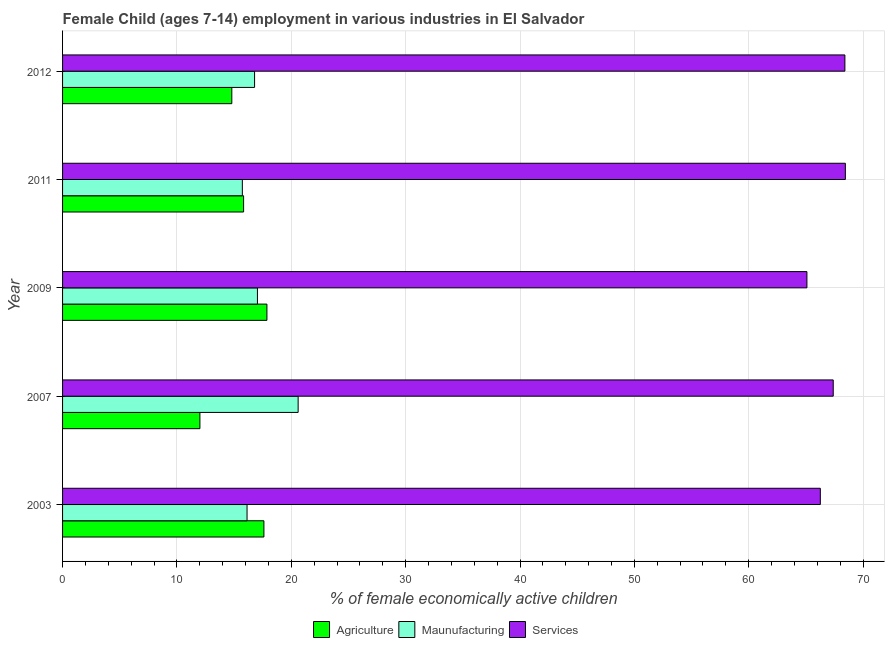How many different coloured bars are there?
Give a very brief answer. 3. How many groups of bars are there?
Ensure brevity in your answer.  5. Are the number of bars per tick equal to the number of legend labels?
Make the answer very short. Yes. Are the number of bars on each tick of the Y-axis equal?
Your response must be concise. Yes. What is the percentage of economically active children in agriculture in 2012?
Your answer should be very brief. 14.8. Across all years, what is the maximum percentage of economically active children in manufacturing?
Your answer should be compact. 20.6. Across all years, what is the minimum percentage of economically active children in services?
Ensure brevity in your answer.  65.09. In which year was the percentage of economically active children in services maximum?
Keep it short and to the point. 2011. In which year was the percentage of economically active children in services minimum?
Provide a short and direct response. 2009. What is the total percentage of economically active children in services in the graph?
Your answer should be very brief. 335.6. What is the difference between the percentage of economically active children in manufacturing in 2007 and that in 2011?
Make the answer very short. 4.88. What is the difference between the percentage of economically active children in agriculture in 2007 and the percentage of economically active children in services in 2003?
Provide a short and direct response. -54.25. What is the average percentage of economically active children in manufacturing per year?
Provide a succinct answer. 17.26. In the year 2003, what is the difference between the percentage of economically active children in manufacturing and percentage of economically active children in services?
Your response must be concise. -50.13. What is the difference between the highest and the lowest percentage of economically active children in manufacturing?
Keep it short and to the point. 4.88. Is the sum of the percentage of economically active children in services in 2003 and 2009 greater than the maximum percentage of economically active children in manufacturing across all years?
Your answer should be compact. Yes. What does the 3rd bar from the top in 2003 represents?
Provide a short and direct response. Agriculture. What does the 2nd bar from the bottom in 2012 represents?
Your answer should be compact. Maunufacturing. How many bars are there?
Provide a succinct answer. 15. How many years are there in the graph?
Make the answer very short. 5. What is the difference between two consecutive major ticks on the X-axis?
Offer a terse response. 10. Does the graph contain grids?
Provide a succinct answer. Yes. How many legend labels are there?
Your answer should be very brief. 3. What is the title of the graph?
Make the answer very short. Female Child (ages 7-14) employment in various industries in El Salvador. What is the label or title of the X-axis?
Ensure brevity in your answer.  % of female economically active children. What is the label or title of the Y-axis?
Your response must be concise. Year. What is the % of female economically active children in Agriculture in 2003?
Your answer should be compact. 17.61. What is the % of female economically active children in Maunufacturing in 2003?
Offer a terse response. 16.13. What is the % of female economically active children of Services in 2003?
Make the answer very short. 66.26. What is the % of female economically active children in Agriculture in 2007?
Provide a succinct answer. 12.01. What is the % of female economically active children of Maunufacturing in 2007?
Offer a very short reply. 20.6. What is the % of female economically active children in Services in 2007?
Give a very brief answer. 67.39. What is the % of female economically active children of Agriculture in 2009?
Give a very brief answer. 17.87. What is the % of female economically active children in Maunufacturing in 2009?
Your answer should be compact. 17.04. What is the % of female economically active children of Services in 2009?
Your answer should be compact. 65.09. What is the % of female economically active children of Agriculture in 2011?
Offer a terse response. 15.83. What is the % of female economically active children of Maunufacturing in 2011?
Make the answer very short. 15.72. What is the % of female economically active children in Services in 2011?
Make the answer very short. 68.45. What is the % of female economically active children of Maunufacturing in 2012?
Provide a succinct answer. 16.79. What is the % of female economically active children in Services in 2012?
Your answer should be very brief. 68.41. Across all years, what is the maximum % of female economically active children in Agriculture?
Keep it short and to the point. 17.87. Across all years, what is the maximum % of female economically active children in Maunufacturing?
Make the answer very short. 20.6. Across all years, what is the maximum % of female economically active children in Services?
Ensure brevity in your answer.  68.45. Across all years, what is the minimum % of female economically active children of Agriculture?
Your answer should be compact. 12.01. Across all years, what is the minimum % of female economically active children in Maunufacturing?
Your response must be concise. 15.72. Across all years, what is the minimum % of female economically active children in Services?
Your answer should be very brief. 65.09. What is the total % of female economically active children of Agriculture in the graph?
Offer a very short reply. 78.12. What is the total % of female economically active children in Maunufacturing in the graph?
Make the answer very short. 86.28. What is the total % of female economically active children in Services in the graph?
Offer a terse response. 335.6. What is the difference between the % of female economically active children in Agriculture in 2003 and that in 2007?
Your answer should be compact. 5.6. What is the difference between the % of female economically active children of Maunufacturing in 2003 and that in 2007?
Offer a very short reply. -4.47. What is the difference between the % of female economically active children of Services in 2003 and that in 2007?
Provide a succinct answer. -1.13. What is the difference between the % of female economically active children of Agriculture in 2003 and that in 2009?
Make the answer very short. -0.26. What is the difference between the % of female economically active children of Maunufacturing in 2003 and that in 2009?
Give a very brief answer. -0.91. What is the difference between the % of female economically active children of Services in 2003 and that in 2009?
Make the answer very short. 1.17. What is the difference between the % of female economically active children in Agriculture in 2003 and that in 2011?
Offer a terse response. 1.78. What is the difference between the % of female economically active children in Maunufacturing in 2003 and that in 2011?
Keep it short and to the point. 0.41. What is the difference between the % of female economically active children of Services in 2003 and that in 2011?
Your response must be concise. -2.19. What is the difference between the % of female economically active children of Agriculture in 2003 and that in 2012?
Offer a terse response. 2.81. What is the difference between the % of female economically active children in Maunufacturing in 2003 and that in 2012?
Keep it short and to the point. -0.66. What is the difference between the % of female economically active children in Services in 2003 and that in 2012?
Your answer should be very brief. -2.15. What is the difference between the % of female economically active children of Agriculture in 2007 and that in 2009?
Offer a terse response. -5.86. What is the difference between the % of female economically active children of Maunufacturing in 2007 and that in 2009?
Keep it short and to the point. 3.56. What is the difference between the % of female economically active children of Agriculture in 2007 and that in 2011?
Give a very brief answer. -3.82. What is the difference between the % of female economically active children in Maunufacturing in 2007 and that in 2011?
Your answer should be very brief. 4.88. What is the difference between the % of female economically active children in Services in 2007 and that in 2011?
Give a very brief answer. -1.06. What is the difference between the % of female economically active children of Agriculture in 2007 and that in 2012?
Ensure brevity in your answer.  -2.79. What is the difference between the % of female economically active children of Maunufacturing in 2007 and that in 2012?
Keep it short and to the point. 3.81. What is the difference between the % of female economically active children in Services in 2007 and that in 2012?
Your response must be concise. -1.02. What is the difference between the % of female economically active children of Agriculture in 2009 and that in 2011?
Your answer should be very brief. 2.04. What is the difference between the % of female economically active children in Maunufacturing in 2009 and that in 2011?
Provide a short and direct response. 1.32. What is the difference between the % of female economically active children in Services in 2009 and that in 2011?
Your answer should be compact. -3.36. What is the difference between the % of female economically active children of Agriculture in 2009 and that in 2012?
Your answer should be compact. 3.07. What is the difference between the % of female economically active children in Services in 2009 and that in 2012?
Make the answer very short. -3.32. What is the difference between the % of female economically active children in Maunufacturing in 2011 and that in 2012?
Keep it short and to the point. -1.07. What is the difference between the % of female economically active children in Agriculture in 2003 and the % of female economically active children in Maunufacturing in 2007?
Give a very brief answer. -2.99. What is the difference between the % of female economically active children of Agriculture in 2003 and the % of female economically active children of Services in 2007?
Give a very brief answer. -49.78. What is the difference between the % of female economically active children in Maunufacturing in 2003 and the % of female economically active children in Services in 2007?
Ensure brevity in your answer.  -51.26. What is the difference between the % of female economically active children in Agriculture in 2003 and the % of female economically active children in Maunufacturing in 2009?
Offer a very short reply. 0.57. What is the difference between the % of female economically active children of Agriculture in 2003 and the % of female economically active children of Services in 2009?
Provide a short and direct response. -47.48. What is the difference between the % of female economically active children of Maunufacturing in 2003 and the % of female economically active children of Services in 2009?
Your answer should be very brief. -48.96. What is the difference between the % of female economically active children in Agriculture in 2003 and the % of female economically active children in Maunufacturing in 2011?
Ensure brevity in your answer.  1.89. What is the difference between the % of female economically active children of Agriculture in 2003 and the % of female economically active children of Services in 2011?
Your answer should be very brief. -50.84. What is the difference between the % of female economically active children in Maunufacturing in 2003 and the % of female economically active children in Services in 2011?
Offer a very short reply. -52.32. What is the difference between the % of female economically active children in Agriculture in 2003 and the % of female economically active children in Maunufacturing in 2012?
Provide a short and direct response. 0.82. What is the difference between the % of female economically active children in Agriculture in 2003 and the % of female economically active children in Services in 2012?
Keep it short and to the point. -50.8. What is the difference between the % of female economically active children in Maunufacturing in 2003 and the % of female economically active children in Services in 2012?
Make the answer very short. -52.28. What is the difference between the % of female economically active children in Agriculture in 2007 and the % of female economically active children in Maunufacturing in 2009?
Provide a short and direct response. -5.03. What is the difference between the % of female economically active children of Agriculture in 2007 and the % of female economically active children of Services in 2009?
Your answer should be compact. -53.08. What is the difference between the % of female economically active children of Maunufacturing in 2007 and the % of female economically active children of Services in 2009?
Give a very brief answer. -44.49. What is the difference between the % of female economically active children of Agriculture in 2007 and the % of female economically active children of Maunufacturing in 2011?
Your answer should be compact. -3.71. What is the difference between the % of female economically active children of Agriculture in 2007 and the % of female economically active children of Services in 2011?
Provide a short and direct response. -56.44. What is the difference between the % of female economically active children of Maunufacturing in 2007 and the % of female economically active children of Services in 2011?
Give a very brief answer. -47.85. What is the difference between the % of female economically active children in Agriculture in 2007 and the % of female economically active children in Maunufacturing in 2012?
Your answer should be compact. -4.78. What is the difference between the % of female economically active children in Agriculture in 2007 and the % of female economically active children in Services in 2012?
Your answer should be compact. -56.4. What is the difference between the % of female economically active children in Maunufacturing in 2007 and the % of female economically active children in Services in 2012?
Your response must be concise. -47.81. What is the difference between the % of female economically active children of Agriculture in 2009 and the % of female economically active children of Maunufacturing in 2011?
Provide a succinct answer. 2.15. What is the difference between the % of female economically active children in Agriculture in 2009 and the % of female economically active children in Services in 2011?
Provide a short and direct response. -50.58. What is the difference between the % of female economically active children in Maunufacturing in 2009 and the % of female economically active children in Services in 2011?
Make the answer very short. -51.41. What is the difference between the % of female economically active children in Agriculture in 2009 and the % of female economically active children in Maunufacturing in 2012?
Your answer should be very brief. 1.08. What is the difference between the % of female economically active children of Agriculture in 2009 and the % of female economically active children of Services in 2012?
Keep it short and to the point. -50.54. What is the difference between the % of female economically active children of Maunufacturing in 2009 and the % of female economically active children of Services in 2012?
Your answer should be very brief. -51.37. What is the difference between the % of female economically active children in Agriculture in 2011 and the % of female economically active children in Maunufacturing in 2012?
Make the answer very short. -0.96. What is the difference between the % of female economically active children in Agriculture in 2011 and the % of female economically active children in Services in 2012?
Offer a very short reply. -52.58. What is the difference between the % of female economically active children in Maunufacturing in 2011 and the % of female economically active children in Services in 2012?
Provide a succinct answer. -52.69. What is the average % of female economically active children in Agriculture per year?
Your answer should be very brief. 15.62. What is the average % of female economically active children of Maunufacturing per year?
Offer a very short reply. 17.26. What is the average % of female economically active children in Services per year?
Make the answer very short. 67.12. In the year 2003, what is the difference between the % of female economically active children of Agriculture and % of female economically active children of Maunufacturing?
Your response must be concise. 1.47. In the year 2003, what is the difference between the % of female economically active children of Agriculture and % of female economically active children of Services?
Provide a succinct answer. -48.66. In the year 2003, what is the difference between the % of female economically active children of Maunufacturing and % of female economically active children of Services?
Your response must be concise. -50.13. In the year 2007, what is the difference between the % of female economically active children in Agriculture and % of female economically active children in Maunufacturing?
Make the answer very short. -8.59. In the year 2007, what is the difference between the % of female economically active children in Agriculture and % of female economically active children in Services?
Your answer should be compact. -55.38. In the year 2007, what is the difference between the % of female economically active children of Maunufacturing and % of female economically active children of Services?
Your response must be concise. -46.79. In the year 2009, what is the difference between the % of female economically active children in Agriculture and % of female economically active children in Maunufacturing?
Offer a very short reply. 0.83. In the year 2009, what is the difference between the % of female economically active children of Agriculture and % of female economically active children of Services?
Provide a short and direct response. -47.22. In the year 2009, what is the difference between the % of female economically active children of Maunufacturing and % of female economically active children of Services?
Keep it short and to the point. -48.05. In the year 2011, what is the difference between the % of female economically active children in Agriculture and % of female economically active children in Maunufacturing?
Offer a very short reply. 0.11. In the year 2011, what is the difference between the % of female economically active children in Agriculture and % of female economically active children in Services?
Your answer should be very brief. -52.62. In the year 2011, what is the difference between the % of female economically active children in Maunufacturing and % of female economically active children in Services?
Keep it short and to the point. -52.73. In the year 2012, what is the difference between the % of female economically active children of Agriculture and % of female economically active children of Maunufacturing?
Your response must be concise. -1.99. In the year 2012, what is the difference between the % of female economically active children in Agriculture and % of female economically active children in Services?
Ensure brevity in your answer.  -53.61. In the year 2012, what is the difference between the % of female economically active children in Maunufacturing and % of female economically active children in Services?
Provide a short and direct response. -51.62. What is the ratio of the % of female economically active children of Agriculture in 2003 to that in 2007?
Your response must be concise. 1.47. What is the ratio of the % of female economically active children in Maunufacturing in 2003 to that in 2007?
Provide a succinct answer. 0.78. What is the ratio of the % of female economically active children in Services in 2003 to that in 2007?
Offer a terse response. 0.98. What is the ratio of the % of female economically active children of Agriculture in 2003 to that in 2009?
Provide a succinct answer. 0.99. What is the ratio of the % of female economically active children in Maunufacturing in 2003 to that in 2009?
Your answer should be compact. 0.95. What is the ratio of the % of female economically active children of Services in 2003 to that in 2009?
Make the answer very short. 1.02. What is the ratio of the % of female economically active children of Agriculture in 2003 to that in 2011?
Ensure brevity in your answer.  1.11. What is the ratio of the % of female economically active children in Maunufacturing in 2003 to that in 2011?
Offer a terse response. 1.03. What is the ratio of the % of female economically active children in Agriculture in 2003 to that in 2012?
Offer a very short reply. 1.19. What is the ratio of the % of female economically active children in Maunufacturing in 2003 to that in 2012?
Your answer should be compact. 0.96. What is the ratio of the % of female economically active children of Services in 2003 to that in 2012?
Your answer should be very brief. 0.97. What is the ratio of the % of female economically active children in Agriculture in 2007 to that in 2009?
Provide a short and direct response. 0.67. What is the ratio of the % of female economically active children of Maunufacturing in 2007 to that in 2009?
Make the answer very short. 1.21. What is the ratio of the % of female economically active children of Services in 2007 to that in 2009?
Your answer should be compact. 1.04. What is the ratio of the % of female economically active children of Agriculture in 2007 to that in 2011?
Provide a succinct answer. 0.76. What is the ratio of the % of female economically active children in Maunufacturing in 2007 to that in 2011?
Offer a very short reply. 1.31. What is the ratio of the % of female economically active children in Services in 2007 to that in 2011?
Offer a very short reply. 0.98. What is the ratio of the % of female economically active children in Agriculture in 2007 to that in 2012?
Your response must be concise. 0.81. What is the ratio of the % of female economically active children of Maunufacturing in 2007 to that in 2012?
Offer a terse response. 1.23. What is the ratio of the % of female economically active children of Services in 2007 to that in 2012?
Make the answer very short. 0.99. What is the ratio of the % of female economically active children of Agriculture in 2009 to that in 2011?
Your answer should be very brief. 1.13. What is the ratio of the % of female economically active children in Maunufacturing in 2009 to that in 2011?
Your response must be concise. 1.08. What is the ratio of the % of female economically active children of Services in 2009 to that in 2011?
Your response must be concise. 0.95. What is the ratio of the % of female economically active children in Agriculture in 2009 to that in 2012?
Your response must be concise. 1.21. What is the ratio of the % of female economically active children of Maunufacturing in 2009 to that in 2012?
Keep it short and to the point. 1.01. What is the ratio of the % of female economically active children in Services in 2009 to that in 2012?
Your answer should be compact. 0.95. What is the ratio of the % of female economically active children of Agriculture in 2011 to that in 2012?
Provide a succinct answer. 1.07. What is the ratio of the % of female economically active children of Maunufacturing in 2011 to that in 2012?
Offer a very short reply. 0.94. What is the difference between the highest and the second highest % of female economically active children of Agriculture?
Keep it short and to the point. 0.26. What is the difference between the highest and the second highest % of female economically active children in Maunufacturing?
Your response must be concise. 3.56. What is the difference between the highest and the lowest % of female economically active children of Agriculture?
Provide a succinct answer. 5.86. What is the difference between the highest and the lowest % of female economically active children in Maunufacturing?
Offer a very short reply. 4.88. What is the difference between the highest and the lowest % of female economically active children of Services?
Ensure brevity in your answer.  3.36. 